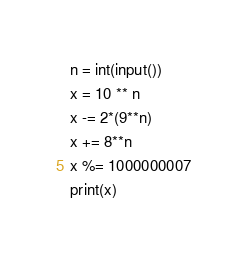Convert code to text. <code><loc_0><loc_0><loc_500><loc_500><_Python_>n = int(input())
x = 10 ** n
x -= 2*(9**n)
x += 8**n
x %= 1000000007
print(x)</code> 